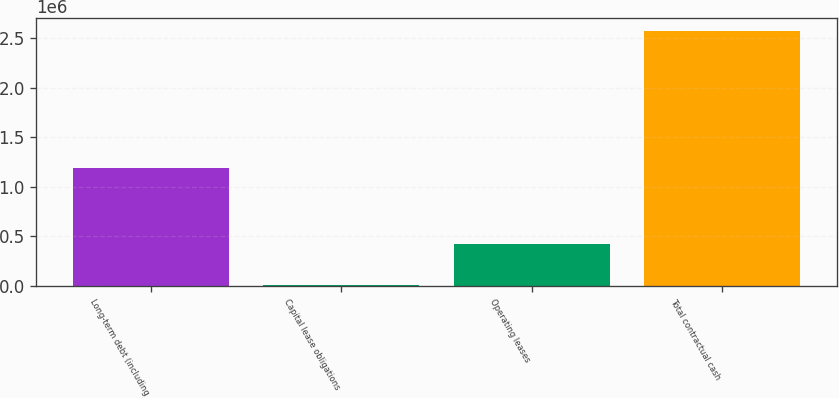Convert chart to OTSL. <chart><loc_0><loc_0><loc_500><loc_500><bar_chart><fcel>Long-term debt (including<fcel>Capital lease obligations<fcel>Operating leases<fcel>Total contractual cash<nl><fcel>1.18852e+06<fcel>9702<fcel>420556<fcel>2.57274e+06<nl></chart> 